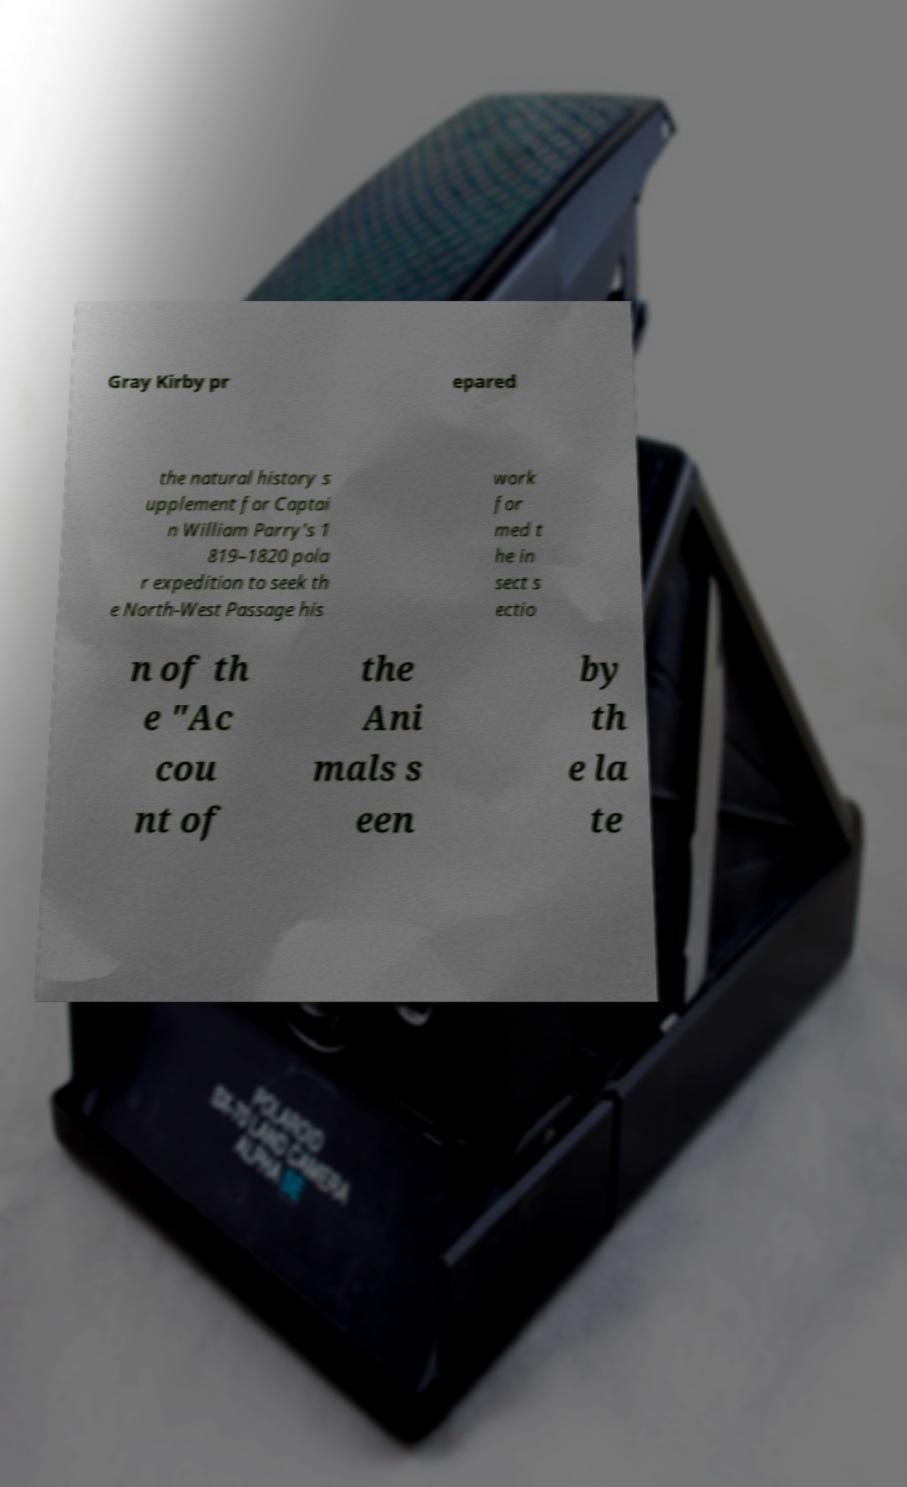I need the written content from this picture converted into text. Can you do that? Gray Kirby pr epared the natural history s upplement for Captai n William Parry's 1 819–1820 pola r expedition to seek th e North-West Passage his work for med t he in sect s ectio n of th e "Ac cou nt of the Ani mals s een by th e la te 